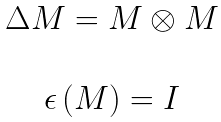<formula> <loc_0><loc_0><loc_500><loc_500>\begin{array} { c } \Delta M = M \otimes M \\ \\ \epsilon \, ( M ) = I \end{array}</formula> 